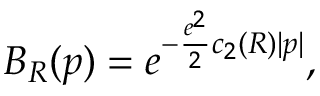Convert formula to latex. <formula><loc_0><loc_0><loc_500><loc_500>B _ { R } ( p ) = e ^ { - \frac { e ^ { 2 } } { 2 } c _ { 2 } ( R ) | p | } ,</formula> 